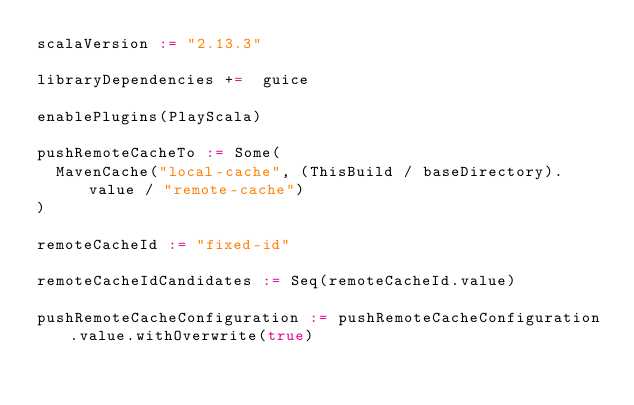<code> <loc_0><loc_0><loc_500><loc_500><_Scala_>scalaVersion := "2.13.3"

libraryDependencies +=  guice

enablePlugins(PlayScala)

pushRemoteCacheTo := Some(
  MavenCache("local-cache", (ThisBuild / baseDirectory).value / "remote-cache")
)

remoteCacheId := "fixed-id"

remoteCacheIdCandidates := Seq(remoteCacheId.value)

pushRemoteCacheConfiguration := pushRemoteCacheConfiguration.value.withOverwrite(true)
</code> 